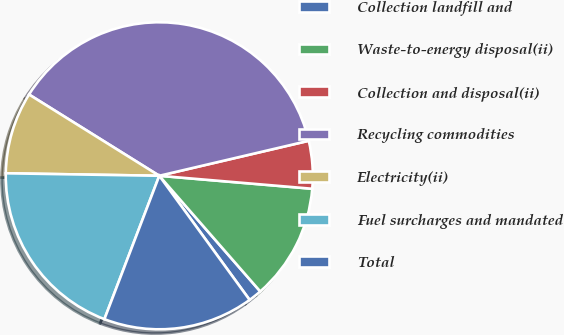<chart> <loc_0><loc_0><loc_500><loc_500><pie_chart><fcel>Collection landfill and<fcel>Waste-to-energy disposal(ii)<fcel>Collection and disposal(ii)<fcel>Recycling commodities<fcel>Electricity(ii)<fcel>Fuel surcharges and mandated<fcel>Total<nl><fcel>1.41%<fcel>12.23%<fcel>5.01%<fcel>37.46%<fcel>8.62%<fcel>19.44%<fcel>15.83%<nl></chart> 